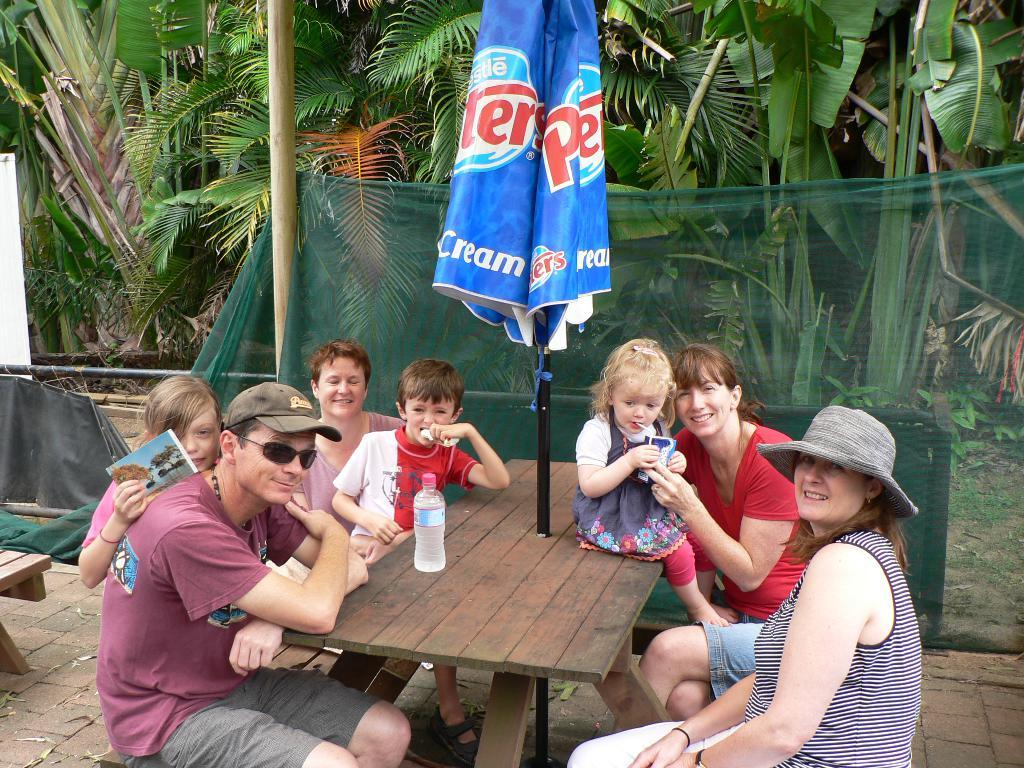What are the people in the image doing? People are sitting on a bench in the image. What is in front of the bench? There is a wooden table in front of the bench. What objects can be seen on the table? A water bottle and a closed umbrella are present on the table. What is visible behind the people? There are trees behind the people. Where are the kittens playing during recess in the image? There are no kittens or any indication of recess present in the image. 